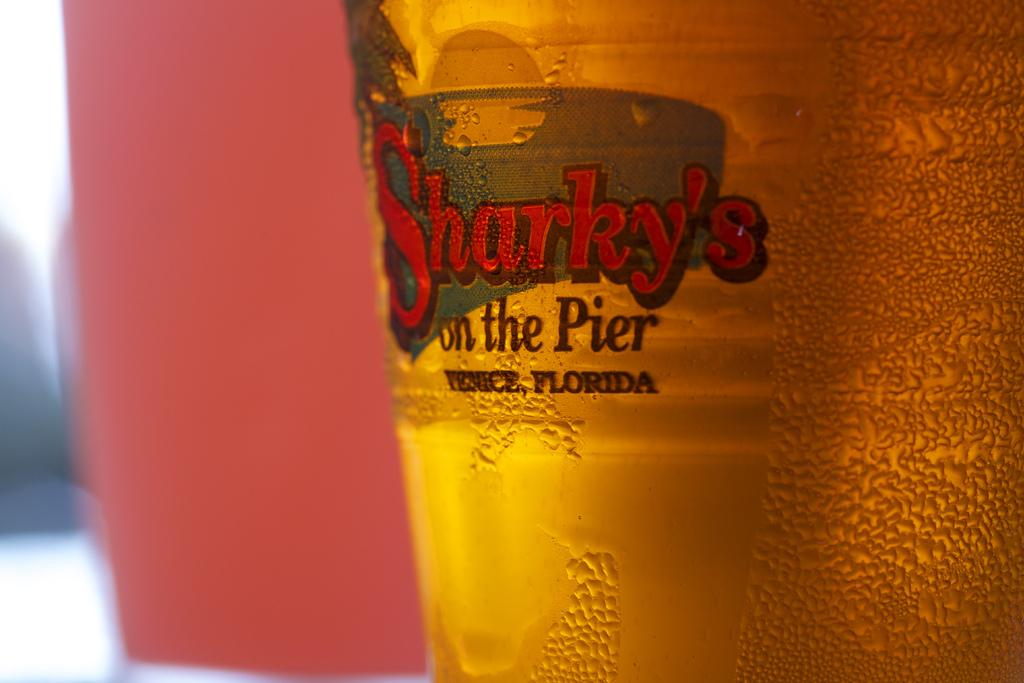Provide a one-sentence caption for the provided image. A bottle of Sharky's on the Pier beer shows it. 